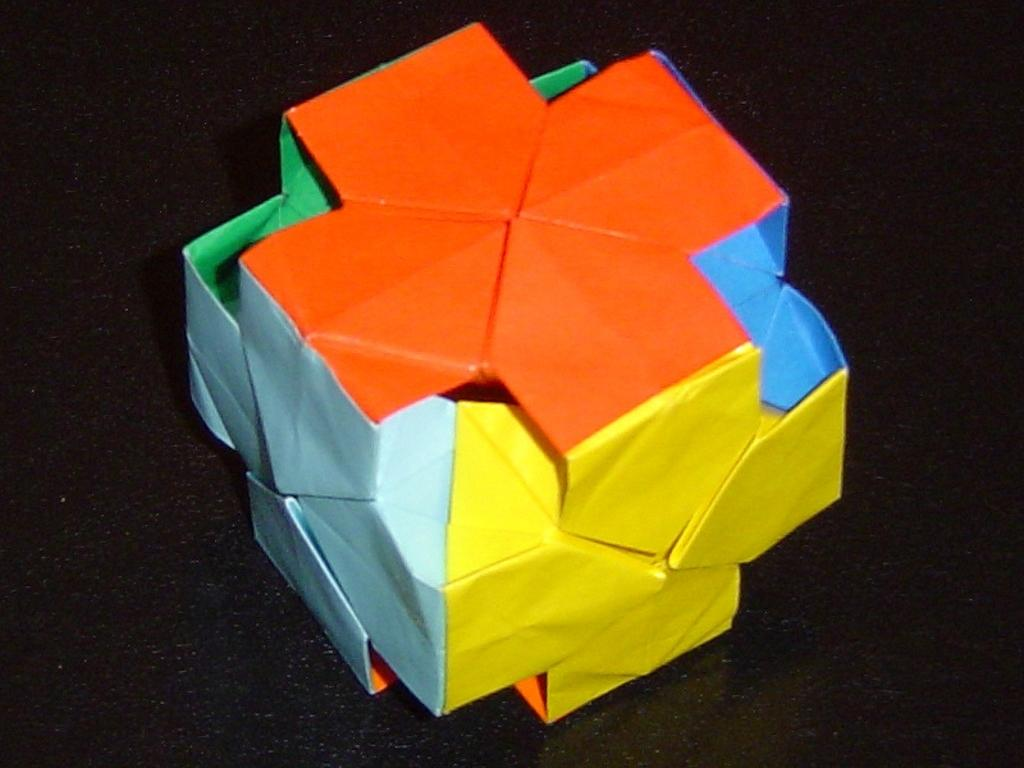What is the main subject of the image? There is an object in the image. Can you describe the object in the image? The object is made up of colorful papers. What type of rice can be seen in the image? There is no rice present in the image; the object is made up of colorful papers. 